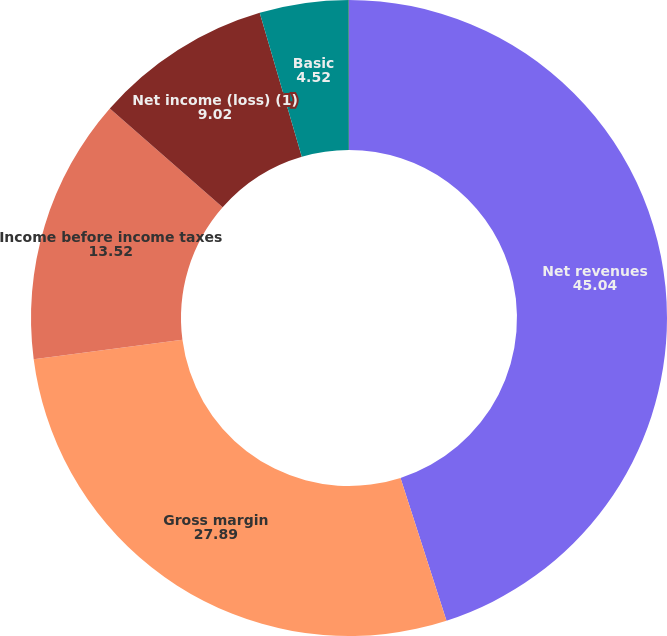Convert chart. <chart><loc_0><loc_0><loc_500><loc_500><pie_chart><fcel>Net revenues<fcel>Gross margin<fcel>Income before income taxes<fcel>Net income (loss) (1)<fcel>Basic<fcel>Diluted (3)<nl><fcel>45.04%<fcel>27.89%<fcel>13.52%<fcel>9.02%<fcel>4.52%<fcel>0.01%<nl></chart> 